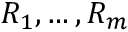Convert formula to latex. <formula><loc_0><loc_0><loc_500><loc_500>R _ { 1 } , \dots , R _ { m }</formula> 